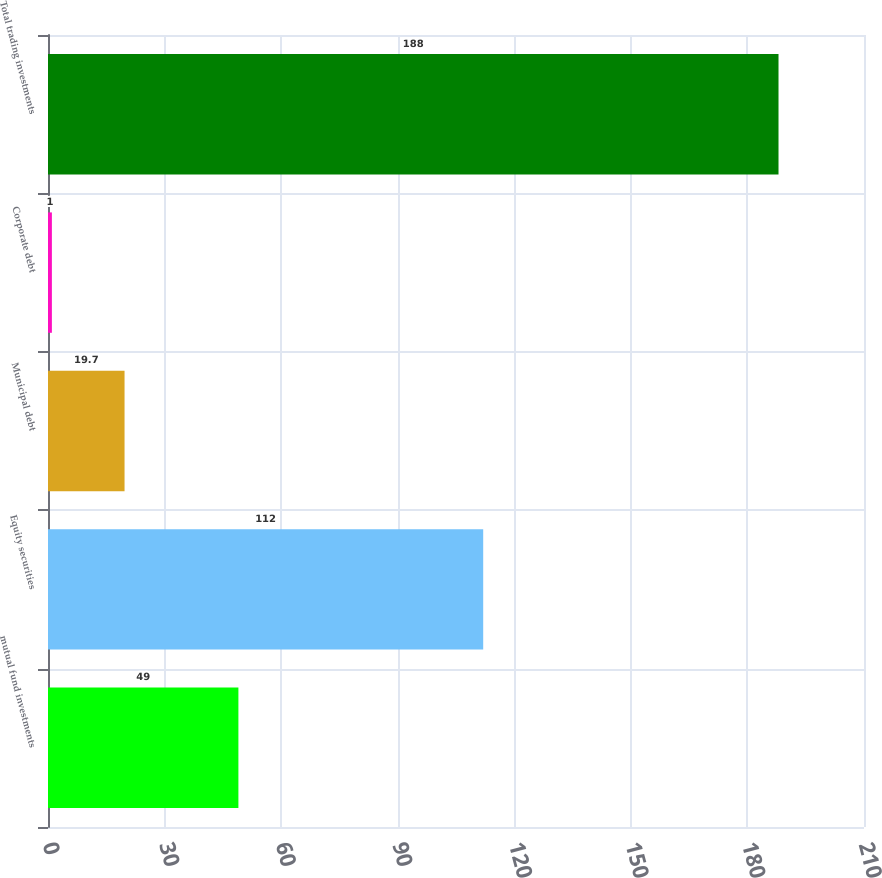Convert chart to OTSL. <chart><loc_0><loc_0><loc_500><loc_500><bar_chart><fcel>mutual fund investments<fcel>Equity securities<fcel>Municipal debt<fcel>Corporate debt<fcel>Total trading investments<nl><fcel>49<fcel>112<fcel>19.7<fcel>1<fcel>188<nl></chart> 